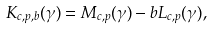Convert formula to latex. <formula><loc_0><loc_0><loc_500><loc_500>K _ { c , p , b } ( \gamma ) = M _ { c , p } ( \gamma ) - b L _ { c , p } ( \gamma ) ,</formula> 